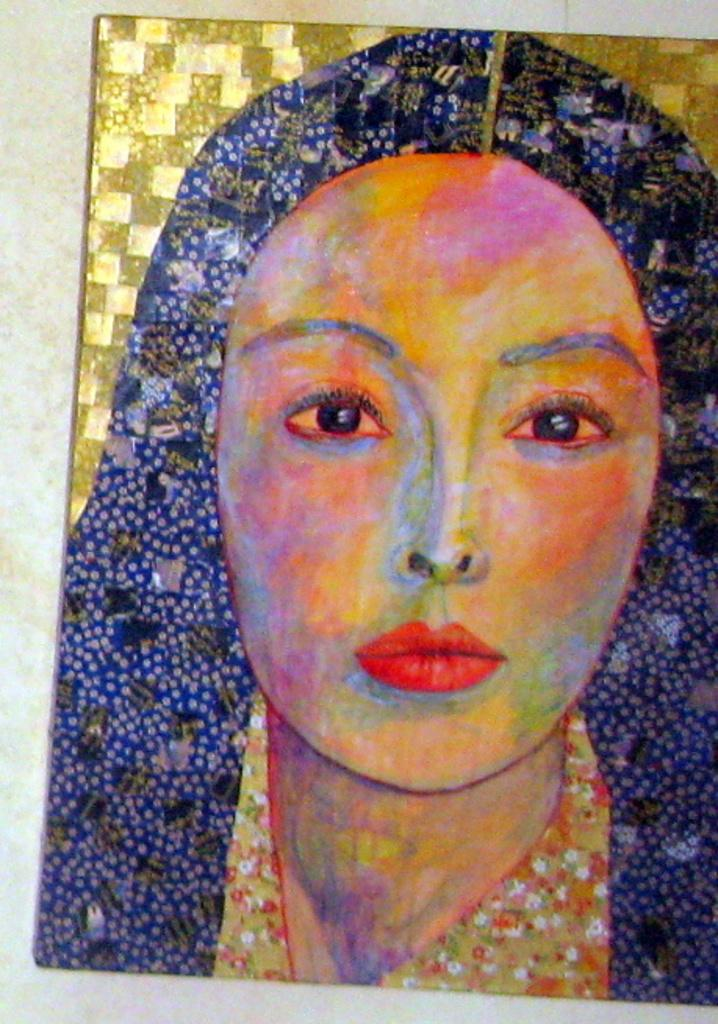What is the main subject of the image? There is a painting in the image. What type of pear is hanging from the locket in the image? There is no pear or locket present in the image; it only features a painting. 